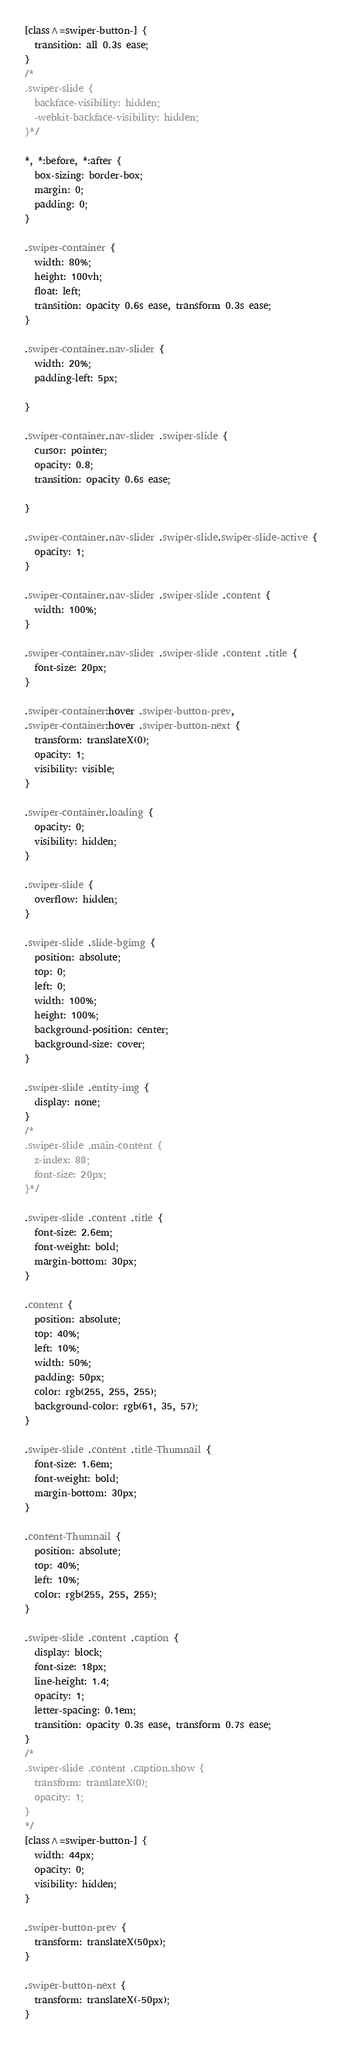<code> <loc_0><loc_0><loc_500><loc_500><_CSS_>[class^=swiper-button-] {
  transition: all 0.3s ease;
}
/*
.swiper-slide {
  backface-visibility: hidden;
  -webkit-backface-visibility: hidden;
}*/

*, *:before, *:after {
  box-sizing: border-box;
  margin: 0;
  padding: 0;
}

.swiper-container {
  width: 80%;
  height: 100vh;
  float: left;
  transition: opacity 0.6s ease, transform 0.3s ease;
}

.swiper-container.nav-slider {
  width: 20%;
  padding-left: 5px;
 
}

.swiper-container.nav-slider .swiper-slide {
  cursor: pointer;
  opacity: 0.8;
  transition: opacity 0.6s ease;
  
}

.swiper-container.nav-slider .swiper-slide.swiper-slide-active {
  opacity: 1;
}

.swiper-container.nav-slider .swiper-slide .content {
  width: 100%;
}

.swiper-container.nav-slider .swiper-slide .content .title {
  font-size: 20px;
}

.swiper-container:hover .swiper-button-prev,
.swiper-container:hover .swiper-button-next {
  transform: translateX(0);
  opacity: 1;
  visibility: visible;
}

.swiper-container.loading {
  opacity: 0;
  visibility: hidden;
}

.swiper-slide {
  overflow: hidden;
}

.swiper-slide .slide-bgimg {
  position: absolute;
  top: 0;
  left: 0;
  width: 100%;
  height: 100%;
  background-position: center;
  background-size: cover;
}

.swiper-slide .entity-img {
  display: none;
}
/*
.swiper-slide .main-content {
  z-index: 88;
  font-size: 20px;
}*/

.swiper-slide .content .title {
  font-size: 2.6em;
  font-weight: bold;
  margin-bottom: 30px;
}

.content {
  position: absolute;
  top: 40%;
  left: 10%;
  width: 50%;
  padding: 50px;
  color: rgb(255, 255, 255);
  background-color: rgb(61, 35, 57);
}

.swiper-slide .content .title-Thumnail {
  font-size: 1.6em;
  font-weight: bold;
  margin-bottom: 30px;
}

.content-Thumnail {
  position: absolute;
  top: 40%;
  left: 10%;
  color: rgb(255, 255, 255);
}

.swiper-slide .content .caption {
  display: block;
  font-size: 18px;
  line-height: 1.4;
  opacity: 1;
  letter-spacing: 0.1em;
  transition: opacity 0.3s ease, transform 0.7s ease;
}
/*
.swiper-slide .content .caption.show {
  transform: translateX(0);
  opacity: 1;
}
*/
[class^=swiper-button-] {
  width: 44px;
  opacity: 0;
  visibility: hidden;
}

.swiper-button-prev {
  transform: translateX(50px);
}

.swiper-button-next {
  transform: translateX(-50px);
}</code> 